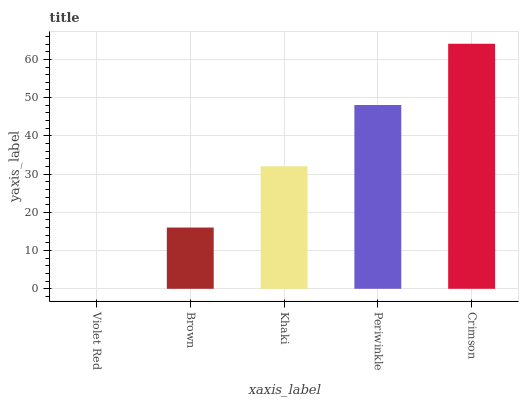Is Violet Red the minimum?
Answer yes or no. Yes. Is Crimson the maximum?
Answer yes or no. Yes. Is Brown the minimum?
Answer yes or no. No. Is Brown the maximum?
Answer yes or no. No. Is Brown greater than Violet Red?
Answer yes or no. Yes. Is Violet Red less than Brown?
Answer yes or no. Yes. Is Violet Red greater than Brown?
Answer yes or no. No. Is Brown less than Violet Red?
Answer yes or no. No. Is Khaki the high median?
Answer yes or no. Yes. Is Khaki the low median?
Answer yes or no. Yes. Is Violet Red the high median?
Answer yes or no. No. Is Crimson the low median?
Answer yes or no. No. 